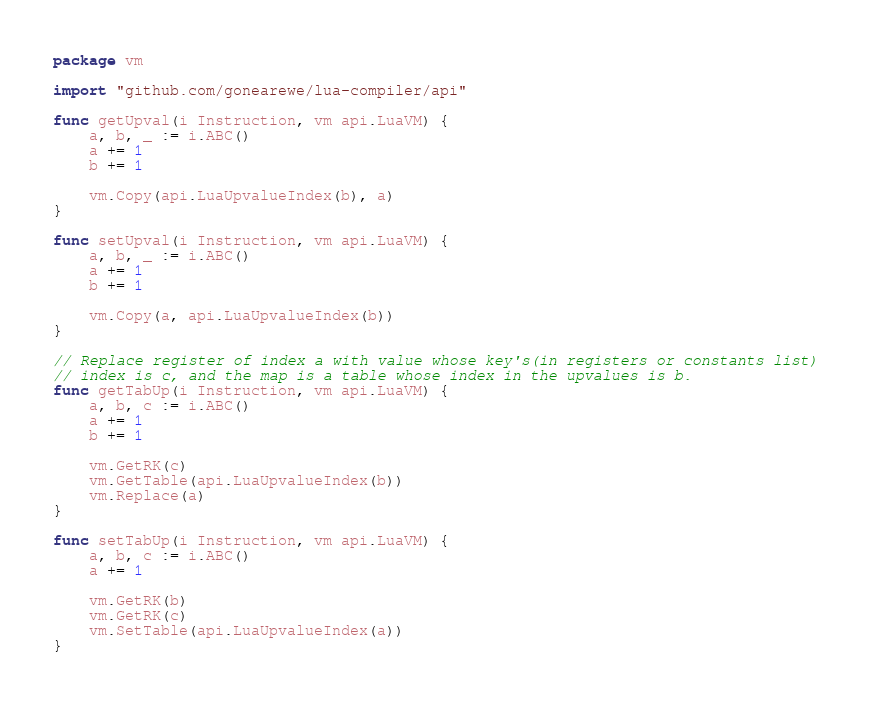<code> <loc_0><loc_0><loc_500><loc_500><_Go_>package vm

import "github.com/gonearewe/lua-compiler/api"

func getUpval(i Instruction, vm api.LuaVM) {
	a, b, _ := i.ABC()
	a += 1
	b += 1

	vm.Copy(api.LuaUpvalueIndex(b), a)
}

func setUpval(i Instruction, vm api.LuaVM) {
	a, b, _ := i.ABC()
	a += 1
	b += 1

	vm.Copy(a, api.LuaUpvalueIndex(b))
}

// Replace register of index a with value whose key's(in registers or constants list)
// index is c, and the map is a table whose index in the upvalues is b.
func getTabUp(i Instruction, vm api.LuaVM) {
	a, b, c := i.ABC()
	a += 1
	b += 1

	vm.GetRK(c)
	vm.GetTable(api.LuaUpvalueIndex(b))
	vm.Replace(a)
}

func setTabUp(i Instruction, vm api.LuaVM) {
	a, b, c := i.ABC()
	a += 1

	vm.GetRK(b)
	vm.GetRK(c)
	vm.SetTable(api.LuaUpvalueIndex(a))
}
</code> 